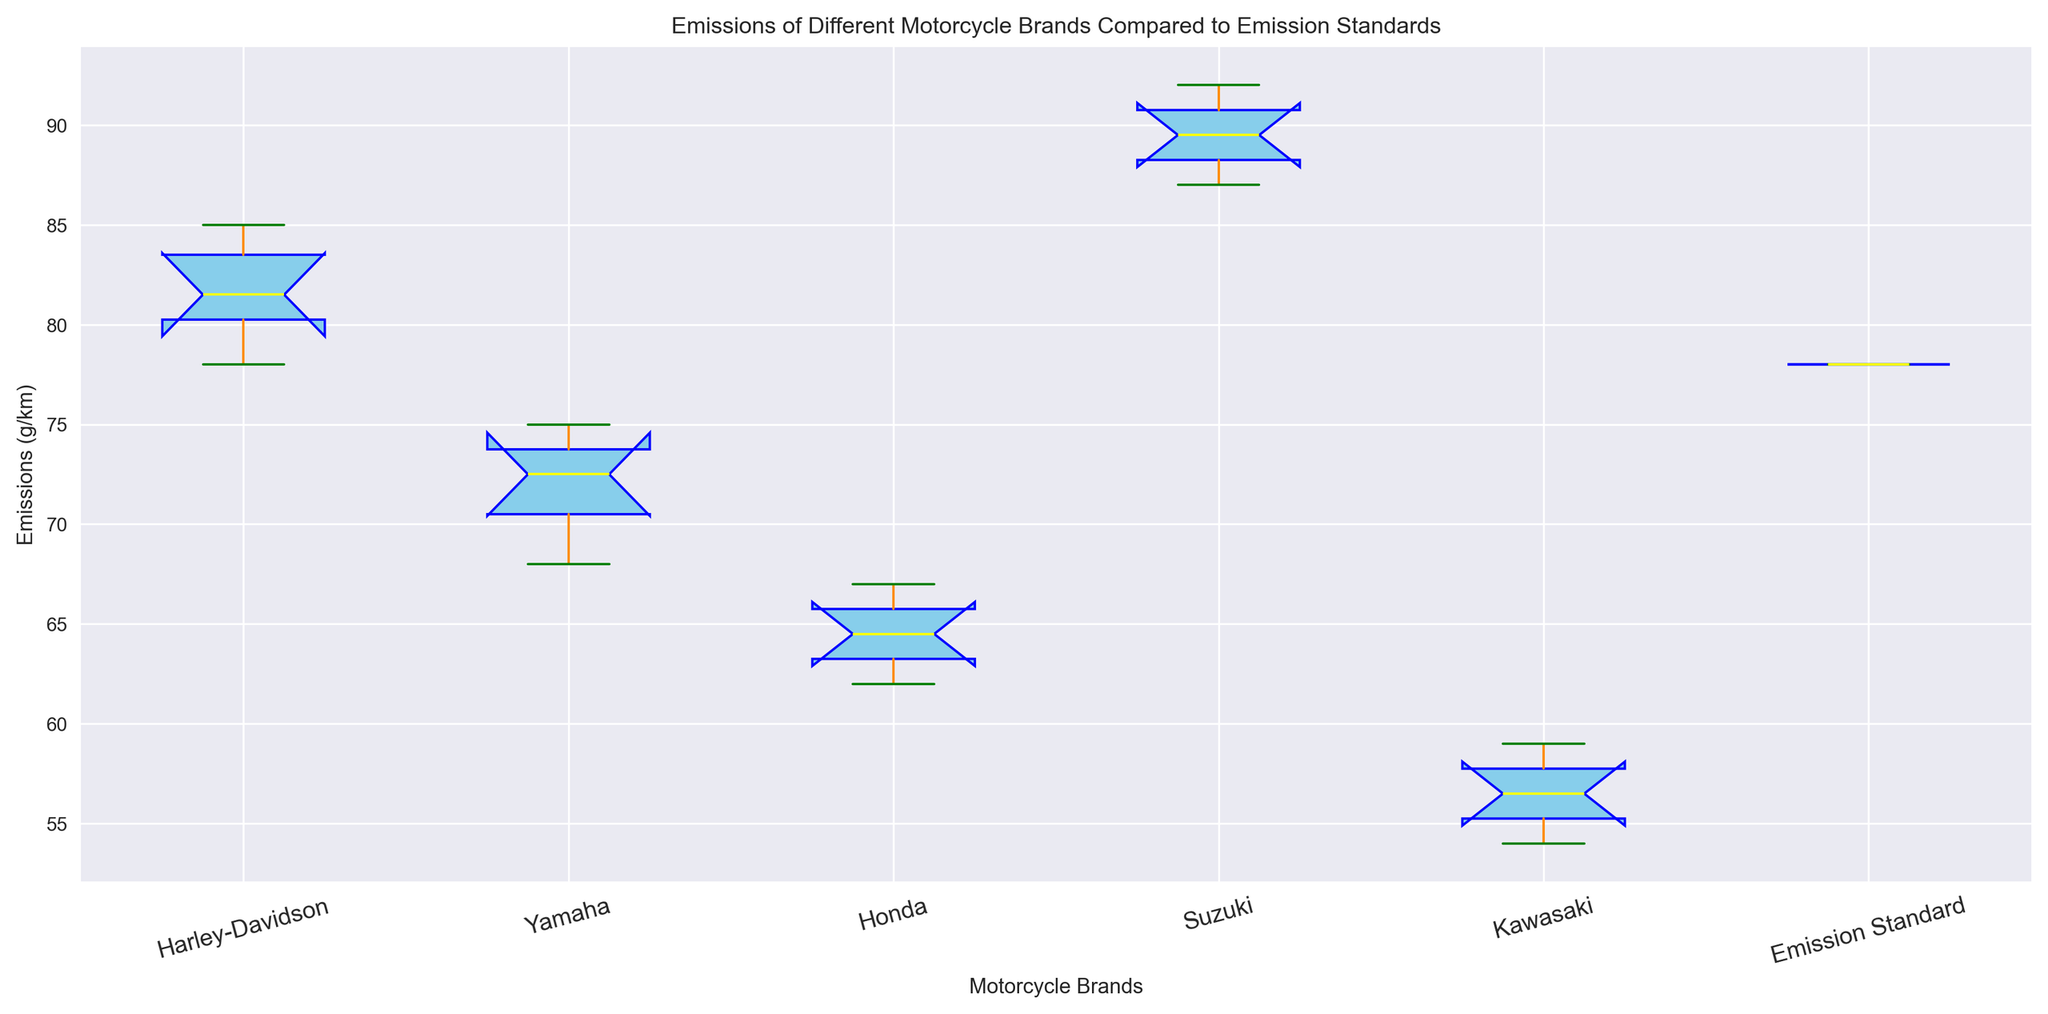Which motorcycle brand has the lowest median emission? Observing the box plot, the median is indicated by the yellow line within each box. The Kawasaki brand has the lowest median, as its yellow line is the lowest among all brands.
Answer: Kawasaki Which motorcycle brand has the highest median emission? Observing the box plot, the highest yellow line, representing the median value, is found in the Suzuki brand.
Answer: Suzuki Are there any brands with emissions below the emission standard of 78 g/km? The emission standard is marked, and any brand's box or whiskers falling below this line indicates emissions below the standard. Suzuki and Harley-Davidson's whiskers extend above 78 g/km, while the others remain below.
Answer: Yes Which brand shows the greatest variability in emissions? Variability can be identified by the length of the box and whiskers. Suzuki has the longest box and whiskers, indicating the greatest spread in its emission values.
Answer: Suzuki What is the approximate interquartile range (IQR) for Yamaha's emissions? IQR is the range between the 75th (top edge of the box) and 25th (bottom edge of the box) percentile values. For Yamaha, this range spans from approximately 72 to 74, which gives an IQR of about 2 g/km.
Answer: 2 g/km Which motorcycle brand has an emission range overlapping with the emission standard of 78 g/km? Overlapping is observed where the whiskers or box of a brand intersect the emission standard line at 78 g/km. Harley-Davidson's whiskers cross the 78 g/km line, indicating overlap.
Answer: Harley-Davidson Compare the median emission of Honda with the emission standard. Which is higher? The median for Honda (yellow line) is lower than the emission standard line at 78 g/km.
Answer: Emission standard How does the median emission of Harley-Davidson compare to Yamaha? Comparing the two yellow lines, Harley-Davidson's median is higher than Yamaha's median emission.
Answer: Harley-Davidson higher What can be inferred about Kawasaki's emissions relative to the emission standard? Since Kawasaki's entire box plot (box and whiskers) falls below the emission standard line at 78 g/km, it suggests that Kawasaki emissions are consistently below the standard.
Answer: Consistently below What is the approximate range (maximum - minimum) of emissions for Suzuki? The range is determined by identifying the maximum (top whisker) and minimum (bottom whisker) values. For Suzuki, these are approximately 92 and 87, resulting in a range of about 5 g/km.
Answer: 5 g/km 